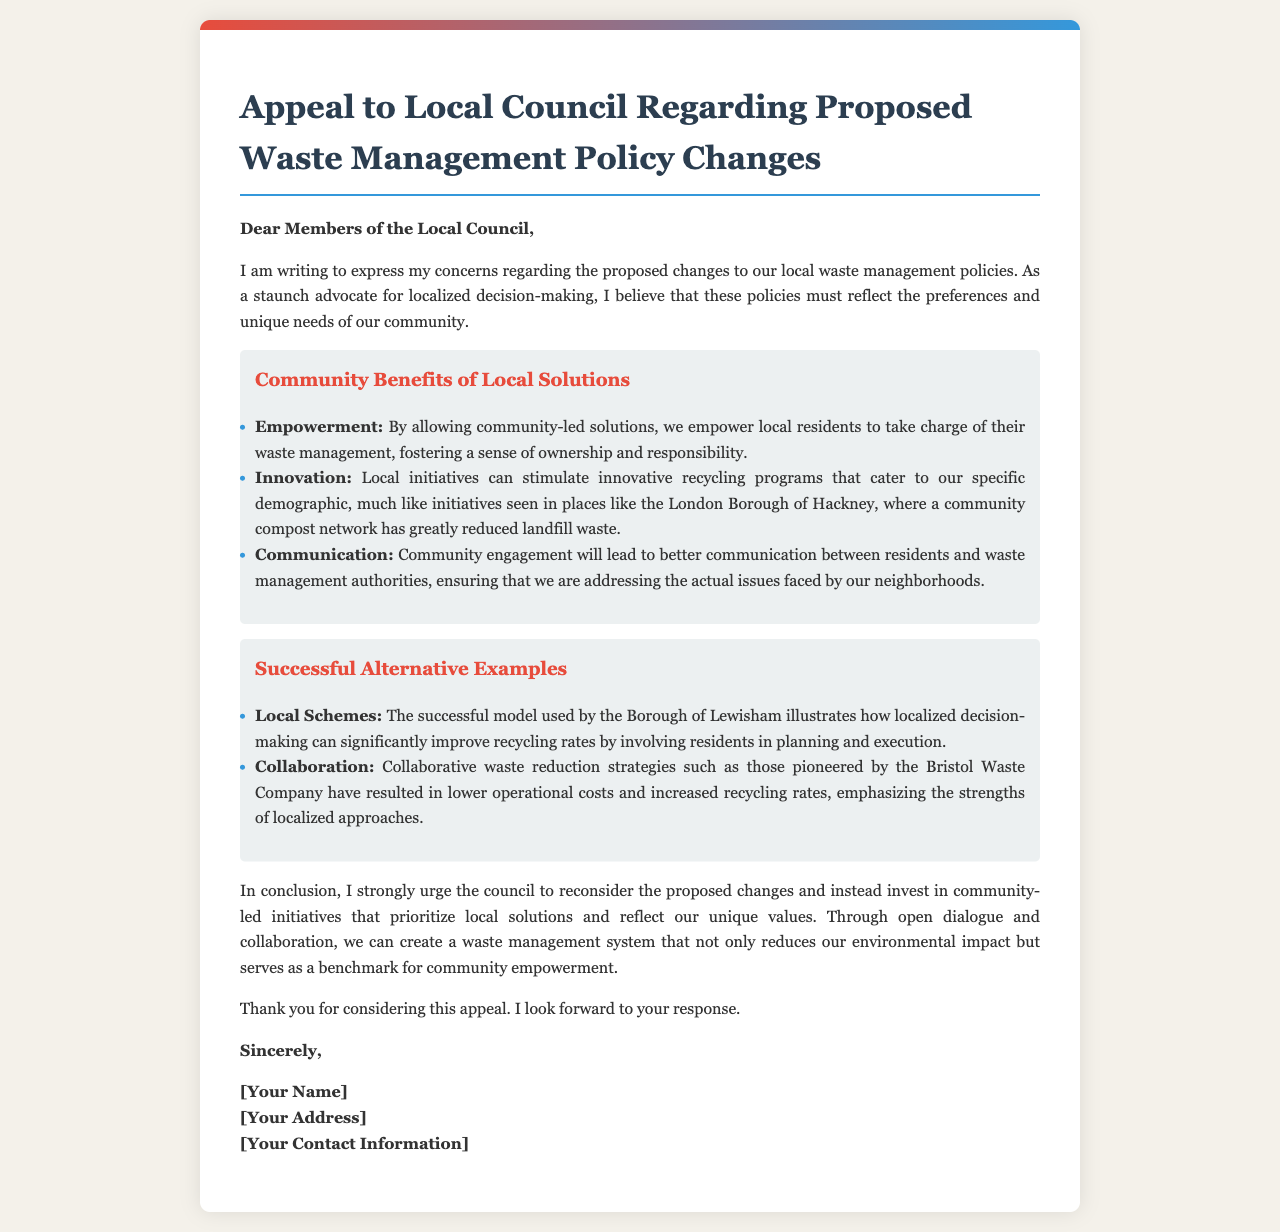what is the title of the document? The title of the document is indicated in the header section of the letter.
Answer: Appeal to Local Council Regarding Proposed Waste Management Policy Changes who is the recipient of the letter? The recipient of the letter is specified at the beginning of the document.
Answer: Members of the Local Council what are two community benefits of local solutions mentioned? The benefits are listed under a specific section in the document.
Answer: Empowerment and Innovation give an example of a successful local scheme mentioned in the letter. The example is provided in the section discussing successful alternative examples.
Answer: Borough of Lewisham what does the writer urge the council to reconsider? The writer's main request is outlined in the concluding paragraphs of the document.
Answer: Proposed changes how many community benefits are listed in the letter? The number of benefits is noted in the document under community benefits.
Answer: Three what is one successful example of collaboration mentioned? This example is found in the section discussing successful alternative examples.
Answer: Bristol Waste Company how does the writer feel about community-led initiatives? The writer's attitude towards community-led initiatives is expressed throughout the letter.
Answer: Strongly supportive what is the closing word of the letter? The closing of the letter is indicated just before the signature.
Answer: Sincerely 